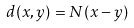Convert formula to latex. <formula><loc_0><loc_0><loc_500><loc_500>d ( x , y ) = N ( x - y )</formula> 